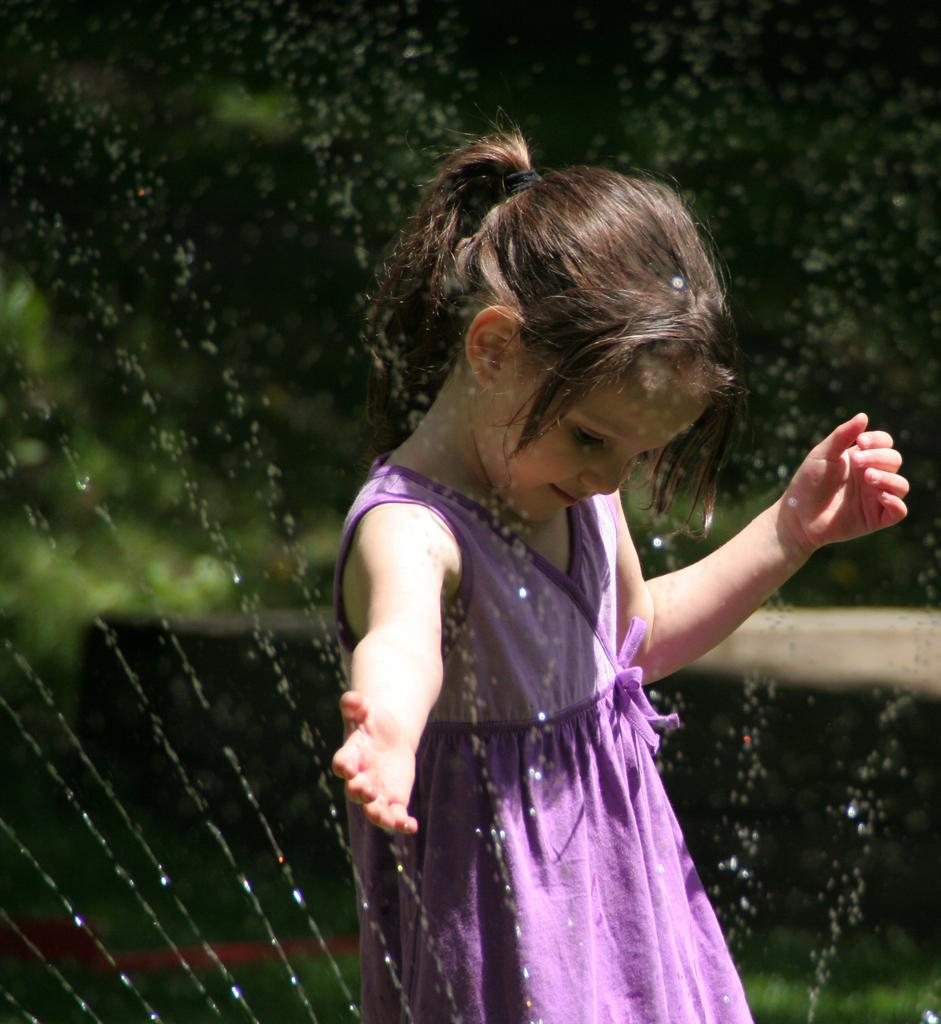What is the main subject of the image? There is a kid in the image. What can be seen in the foreground of the image? There are water sprinkles in the image. Can you describe the background of the image? The background of the image is blurred. What type of screw can be seen in the ear of the kid in the image? There is no screw or ear visible in the image; it features a kid and water sprinkles in the foreground. What type of lace is the kid wearing in the image? There is no lace visible in the image; the focus is on the kid and the water sprinkles. 